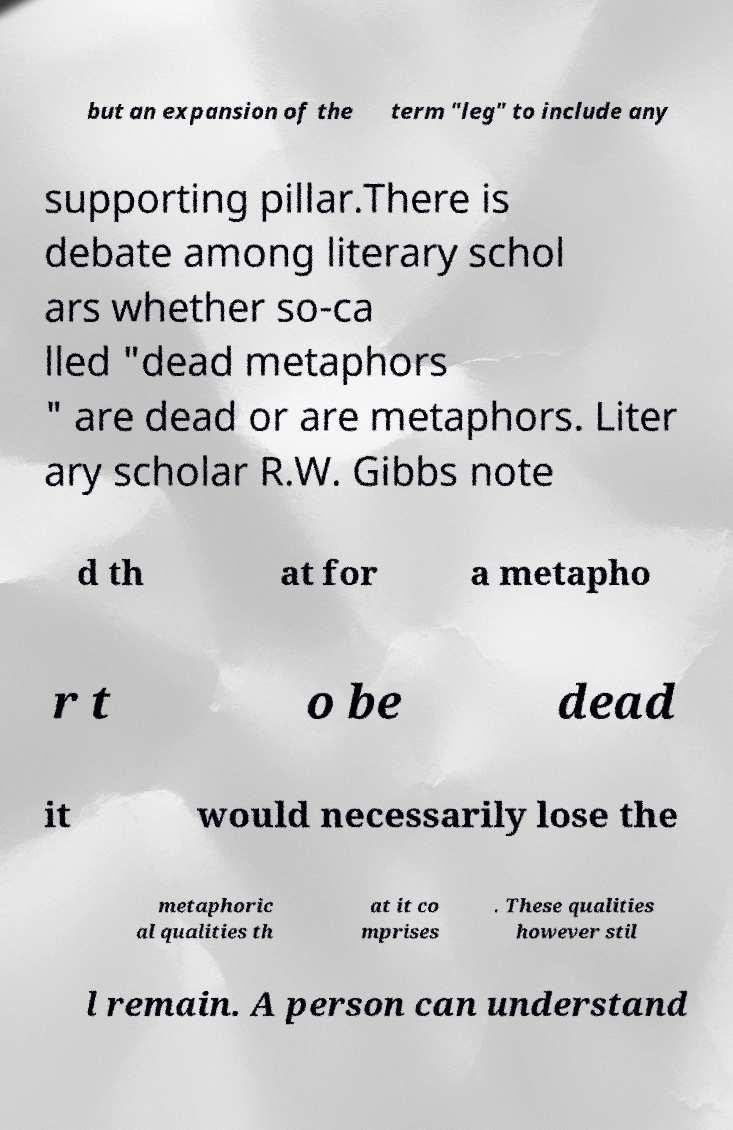Please identify and transcribe the text found in this image. but an expansion of the term "leg" to include any supporting pillar.There is debate among literary schol ars whether so-ca lled "dead metaphors " are dead or are metaphors. Liter ary scholar R.W. Gibbs note d th at for a metapho r t o be dead it would necessarily lose the metaphoric al qualities th at it co mprises . These qualities however stil l remain. A person can understand 